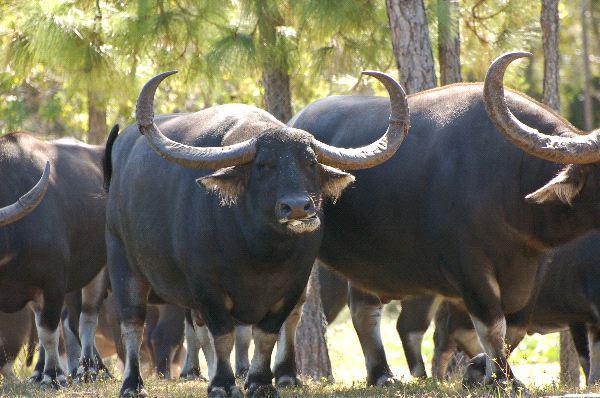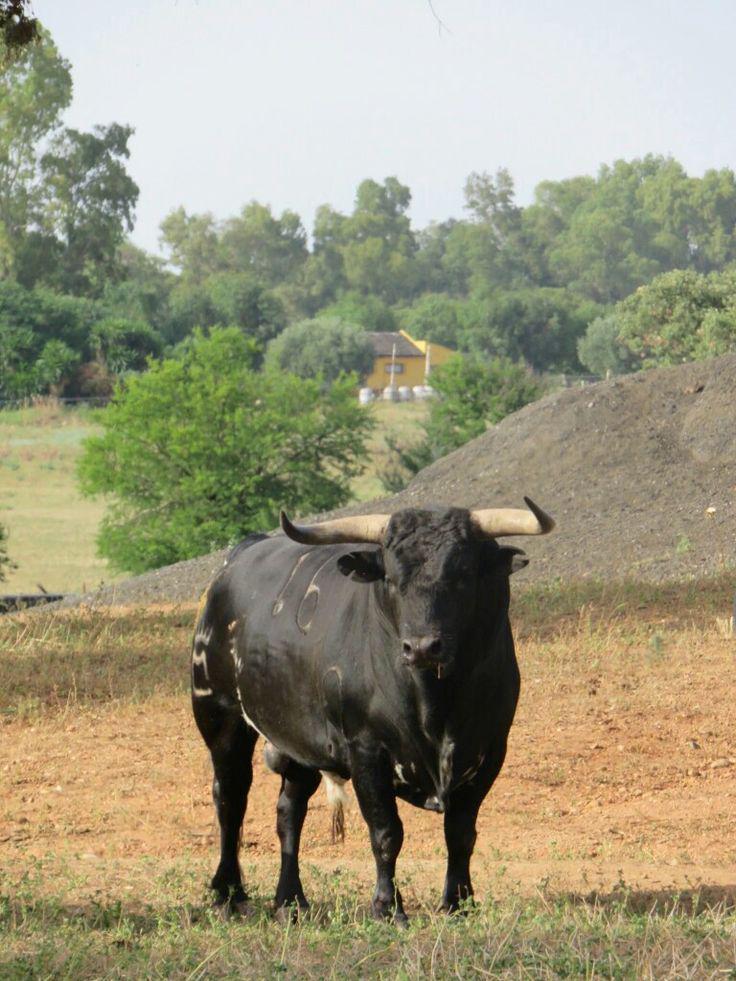The first image is the image on the left, the second image is the image on the right. Examine the images to the left and right. Is the description "There are exactly three animals." accurate? Answer yes or no. No. 